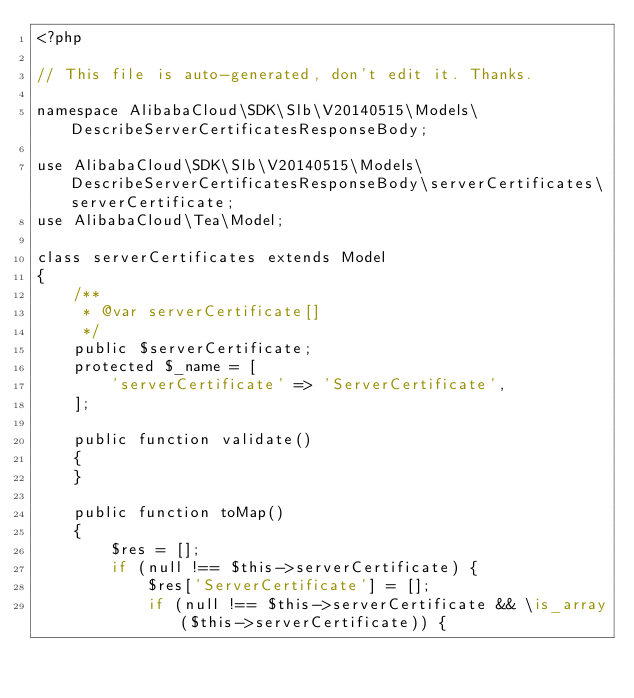Convert code to text. <code><loc_0><loc_0><loc_500><loc_500><_PHP_><?php

// This file is auto-generated, don't edit it. Thanks.

namespace AlibabaCloud\SDK\Slb\V20140515\Models\DescribeServerCertificatesResponseBody;

use AlibabaCloud\SDK\Slb\V20140515\Models\DescribeServerCertificatesResponseBody\serverCertificates\serverCertificate;
use AlibabaCloud\Tea\Model;

class serverCertificates extends Model
{
    /**
     * @var serverCertificate[]
     */
    public $serverCertificate;
    protected $_name = [
        'serverCertificate' => 'ServerCertificate',
    ];

    public function validate()
    {
    }

    public function toMap()
    {
        $res = [];
        if (null !== $this->serverCertificate) {
            $res['ServerCertificate'] = [];
            if (null !== $this->serverCertificate && \is_array($this->serverCertificate)) {</code> 